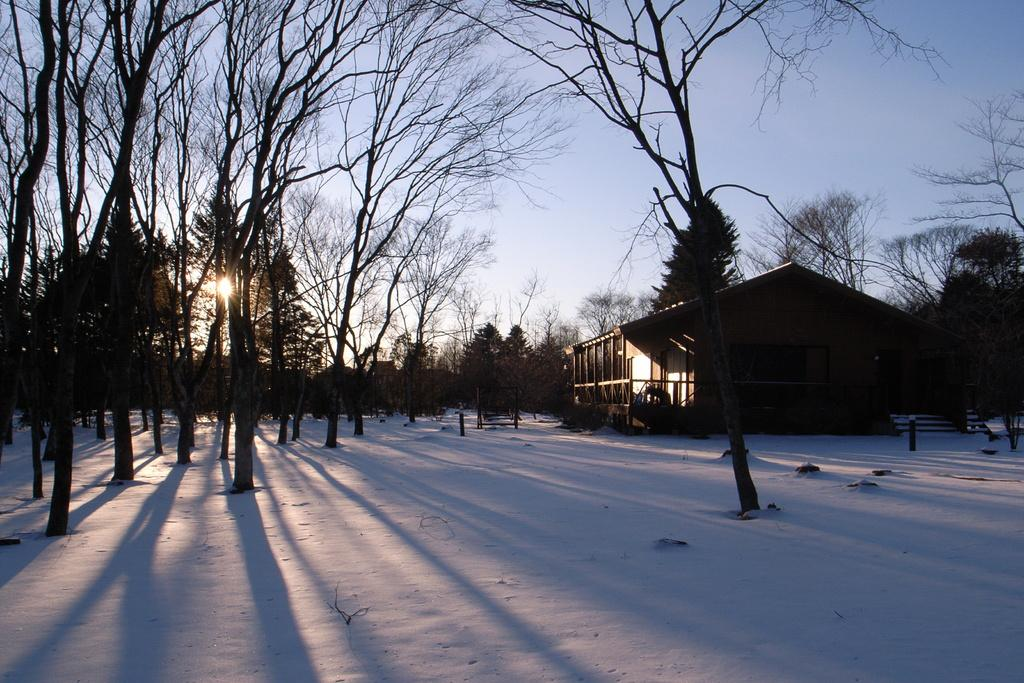What type of structure is visible in the image? There is a house in the image. What is the weather like in the image? There is snow in the image, indicating a cold and likely wintery scene. What type of vegetation is present in the image? There are trees in the image. What else can be seen in the image that is not a part of the house or trees? There are poles in the image. What is visible in the background of the image? The sky is visible in the background of the image. Can you see any quicksand in the image? No, there is no quicksand present in the image. Is there a goat visible in the image? No, there is no goat present in the image. 